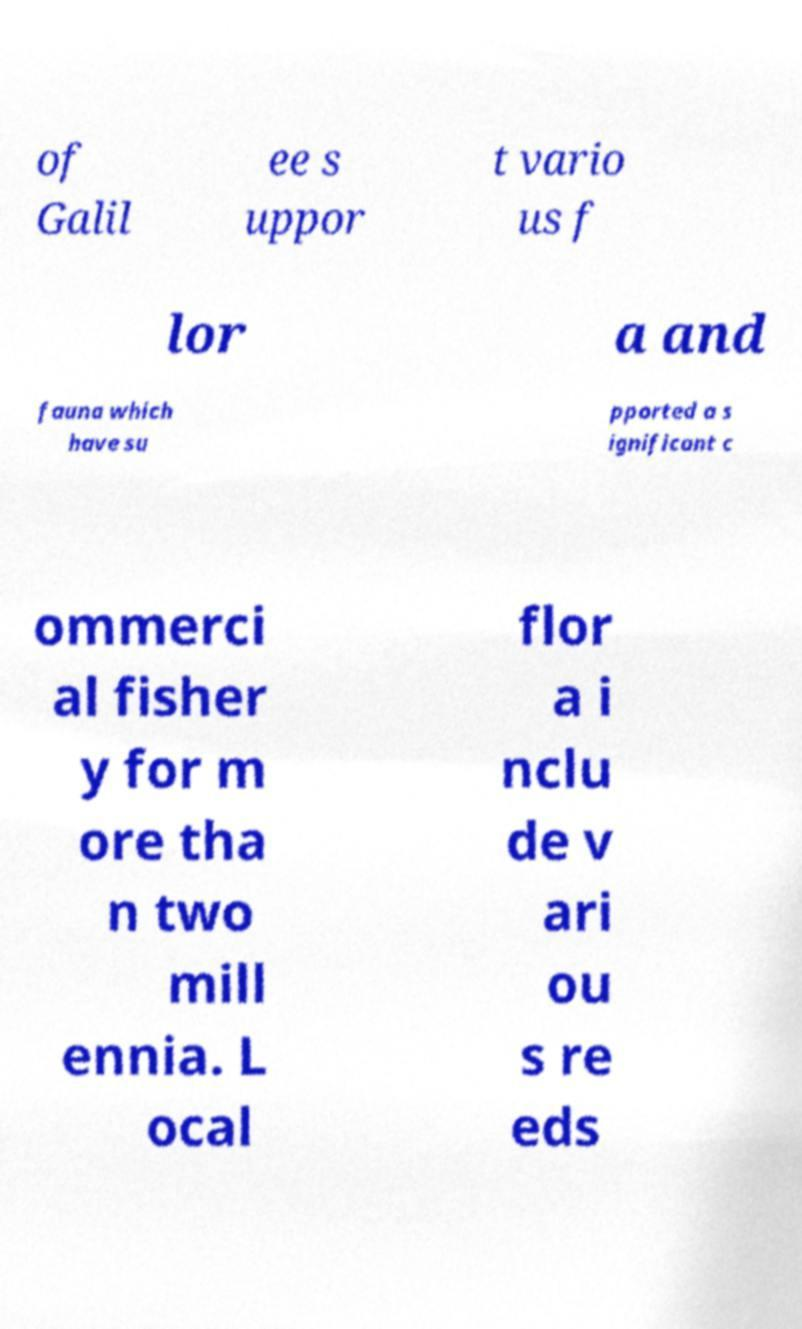I need the written content from this picture converted into text. Can you do that? of Galil ee s uppor t vario us f lor a and fauna which have su pported a s ignificant c ommerci al fisher y for m ore tha n two mill ennia. L ocal flor a i nclu de v ari ou s re eds 